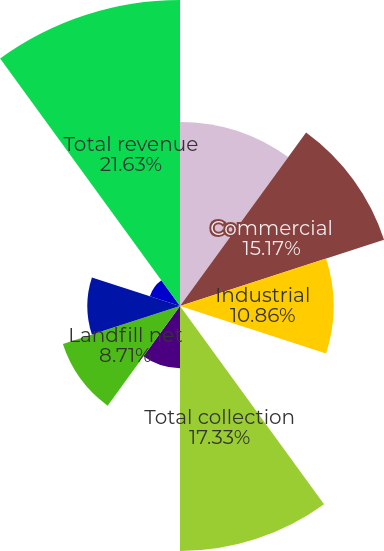Convert chart to OTSL. <chart><loc_0><loc_0><loc_500><loc_500><pie_chart><fcel>Residential<fcel>Commercial<fcel>Industrial<fcel>Other<fcel>Total collection<fcel>Transfer net<fcel>Landfill net<fcel>Sale of recycled commodities<fcel>Other non-core<fcel>Total revenue<nl><fcel>13.02%<fcel>15.17%<fcel>10.86%<fcel>0.09%<fcel>17.33%<fcel>4.4%<fcel>8.71%<fcel>6.55%<fcel>2.24%<fcel>21.64%<nl></chart> 